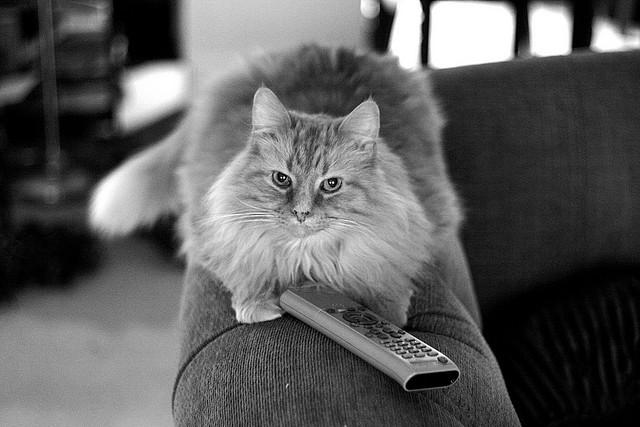What is the cat laying on?
Give a very brief answer. Couch. Is the cat about to pounce?
Be succinct. No. Is this a black and white picture?
Short answer required. Yes. Is the cat watching TV?
Keep it brief. Yes. 